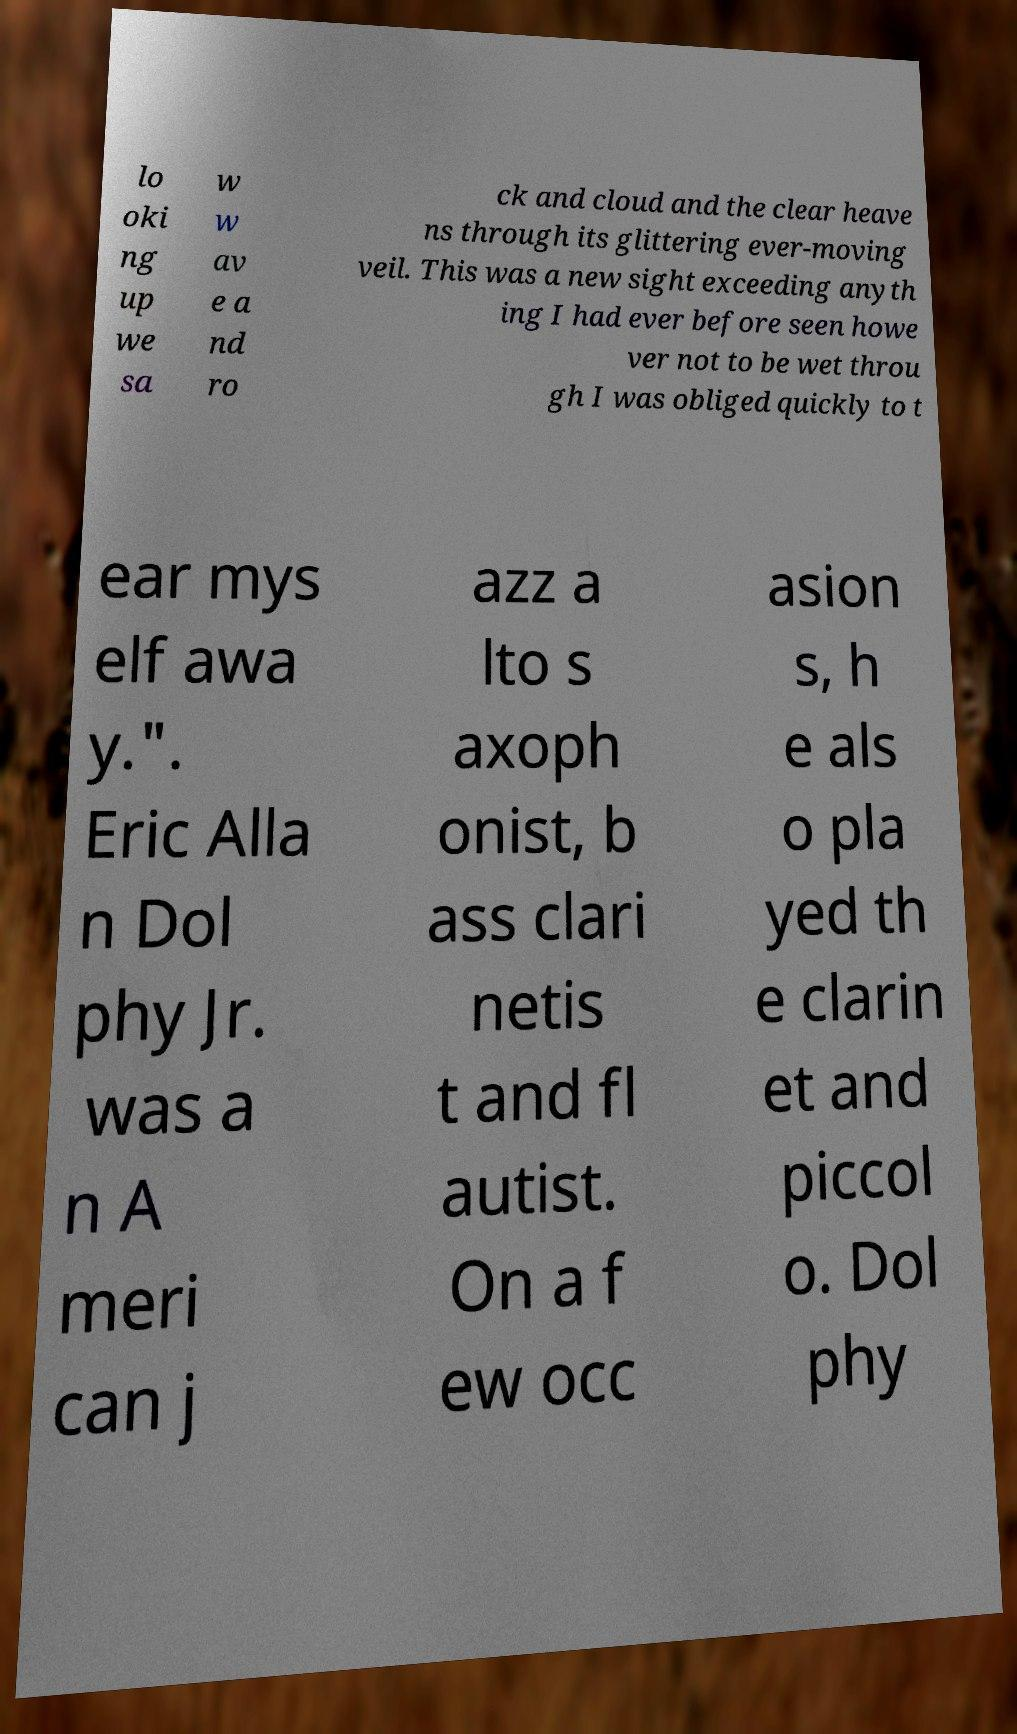Please identify and transcribe the text found in this image. lo oki ng up we sa w w av e a nd ro ck and cloud and the clear heave ns through its glittering ever-moving veil. This was a new sight exceeding anyth ing I had ever before seen howe ver not to be wet throu gh I was obliged quickly to t ear mys elf awa y.". Eric Alla n Dol phy Jr. was a n A meri can j azz a lto s axoph onist, b ass clari netis t and fl autist. On a f ew occ asion s, h e als o pla yed th e clarin et and piccol o. Dol phy 